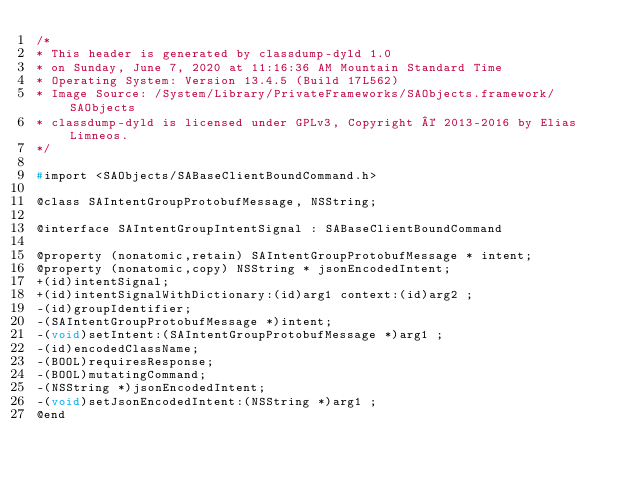<code> <loc_0><loc_0><loc_500><loc_500><_C_>/*
* This header is generated by classdump-dyld 1.0
* on Sunday, June 7, 2020 at 11:16:36 AM Mountain Standard Time
* Operating System: Version 13.4.5 (Build 17L562)
* Image Source: /System/Library/PrivateFrameworks/SAObjects.framework/SAObjects
* classdump-dyld is licensed under GPLv3, Copyright © 2013-2016 by Elias Limneos.
*/

#import <SAObjects/SABaseClientBoundCommand.h>

@class SAIntentGroupProtobufMessage, NSString;

@interface SAIntentGroupIntentSignal : SABaseClientBoundCommand

@property (nonatomic,retain) SAIntentGroupProtobufMessage * intent; 
@property (nonatomic,copy) NSString * jsonEncodedIntent; 
+(id)intentSignal;
+(id)intentSignalWithDictionary:(id)arg1 context:(id)arg2 ;
-(id)groupIdentifier;
-(SAIntentGroupProtobufMessage *)intent;
-(void)setIntent:(SAIntentGroupProtobufMessage *)arg1 ;
-(id)encodedClassName;
-(BOOL)requiresResponse;
-(BOOL)mutatingCommand;
-(NSString *)jsonEncodedIntent;
-(void)setJsonEncodedIntent:(NSString *)arg1 ;
@end

</code> 